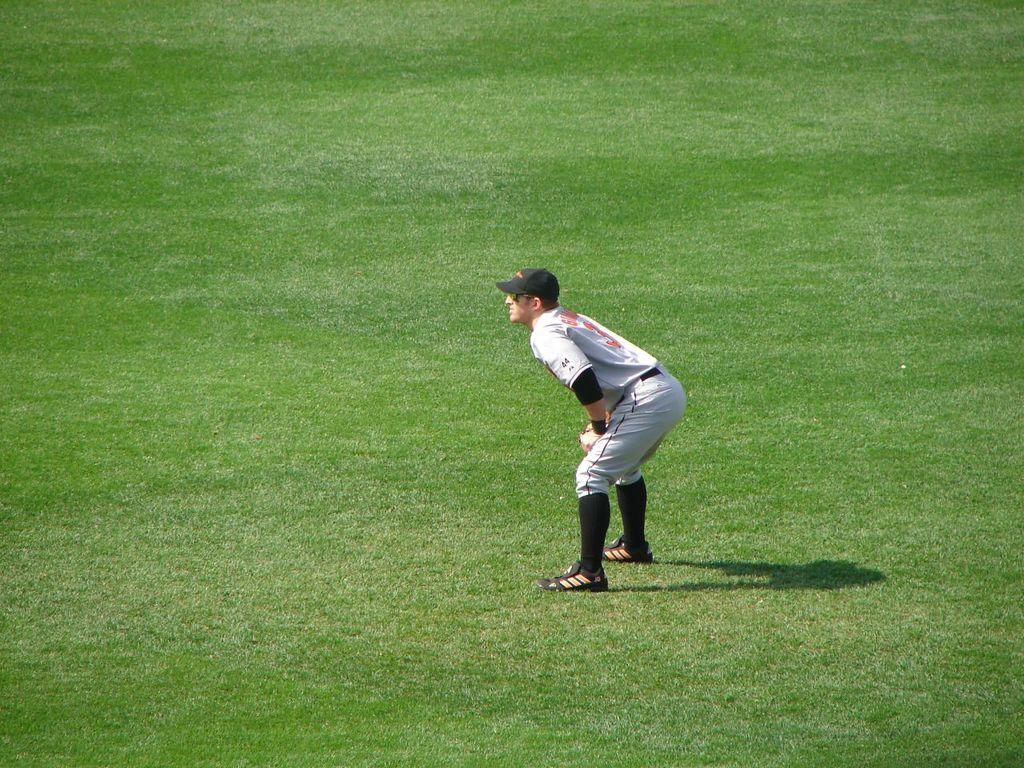How would you summarize this image in a sentence or two? This picture is clicked outside. In the center there is a person wearing white color t-shirt, black color hat, sunglasses and standing on the ground and bending forward and we can see the ground is covered with the green grass and we can see the shadow of a person on the ground. 